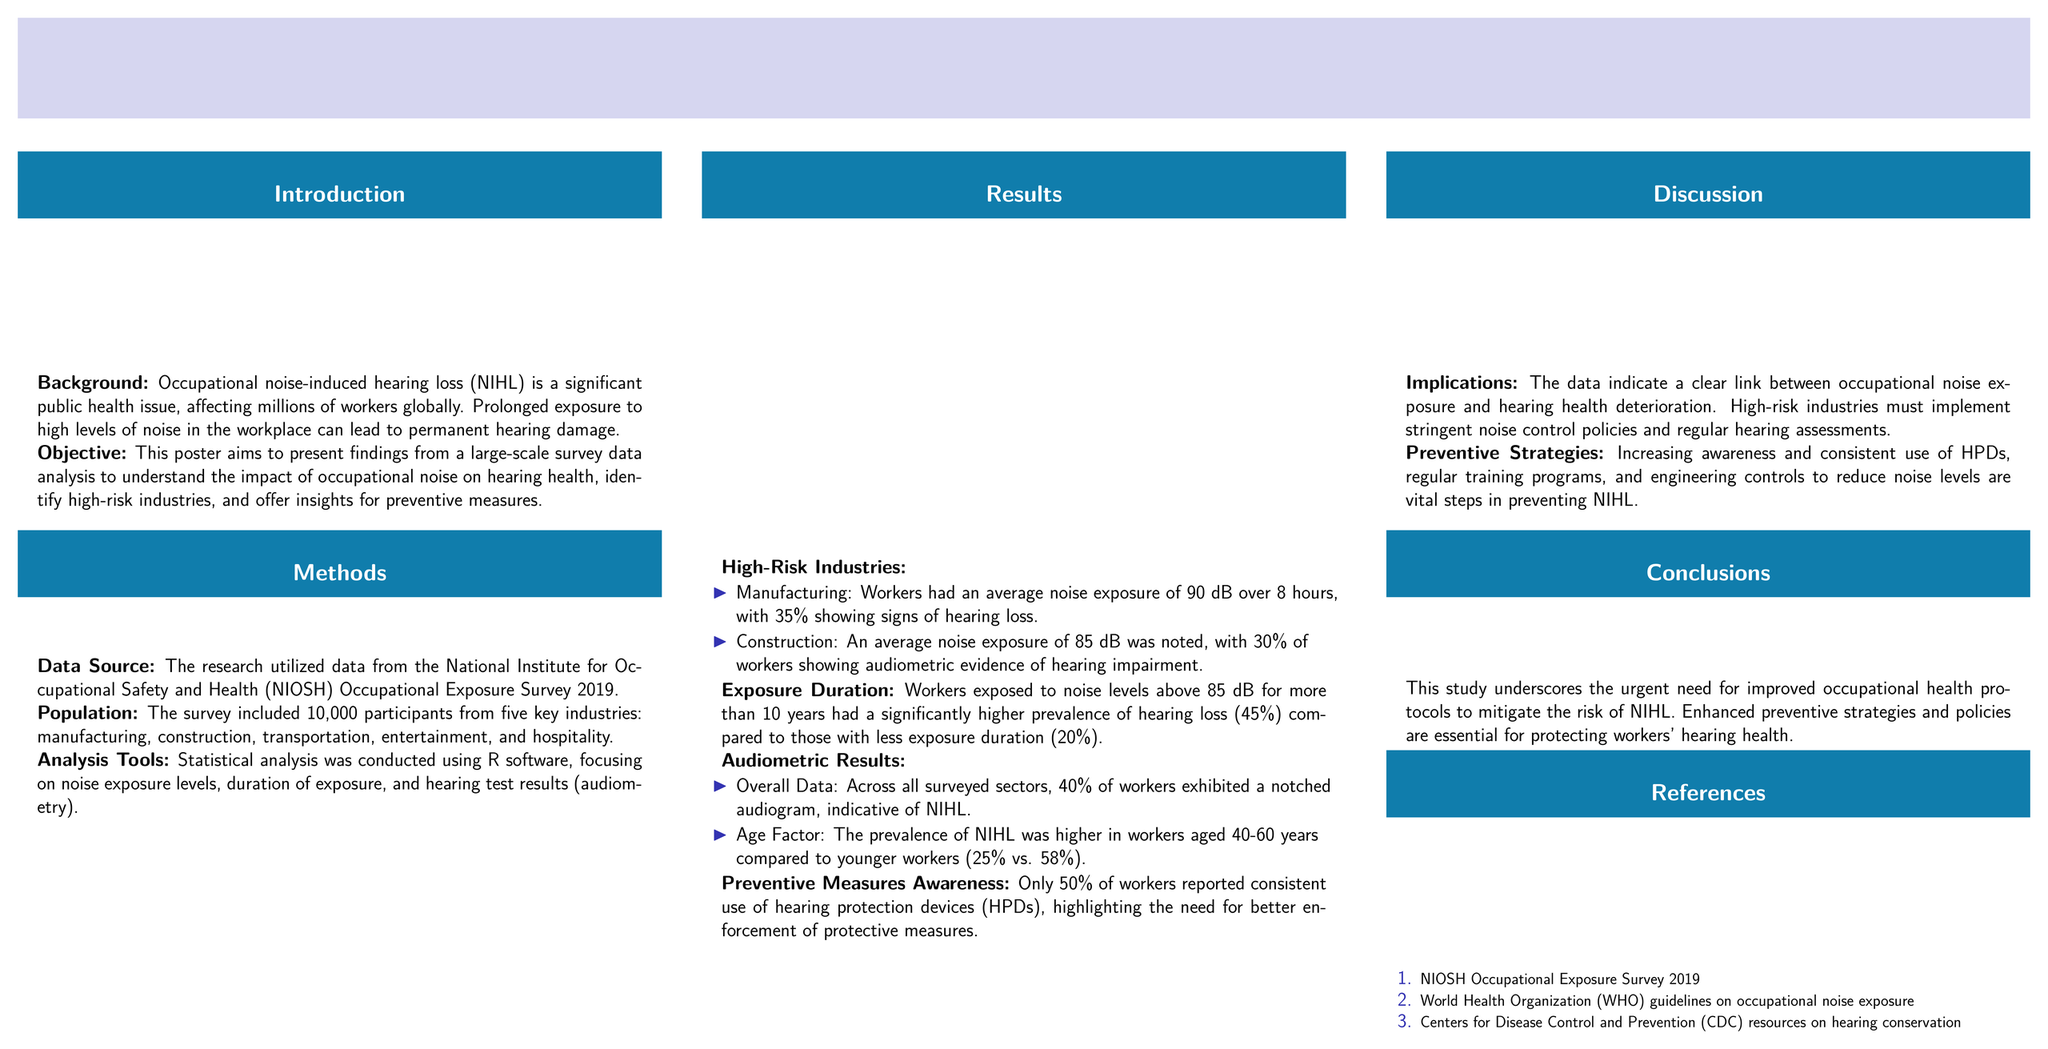What is the objective of the poster? The objective is to present findings from a large-scale survey data analysis to understand the impact of occupational noise on hearing health.
Answer: Understanding the impact of occupational noise on hearing health How many participants were included in the survey? The survey included a total of 10,000 participants.
Answer: 10,000 participants Which industry had the highest percentage of workers showing signs of hearing loss? The industry with the highest percentage is manufacturing, with 35% showing signs of hearing loss.
Answer: Manufacturing What percentage of workers reported consistent use of hearing protection devices? Only 50% of workers reported consistent use of hearing protection devices.
Answer: 50% What is the average noise exposure level in construction? The average noise exposure level noted in construction is 85 dB.
Answer: 85 dB What was the prevalence of NIHL in workers aged 40-60 years? The prevalence of NIHL in this age group is 58%.
Answer: 58% What do the authors recommend for preventing NIHL? The authors recommend increasing awareness and consistent use of HPDs.
Answer: Increasing awareness and consistent use of HPDs What data source was used for this research? The data source utilized was the NIOSH Occupational Exposure Survey 2019.
Answer: NIOSH Occupational Exposure Survey 2019 What is indicated by a notched audiogram? A notched audiogram is indicative of noise-induced hearing loss.
Answer: Noise-induced hearing loss 